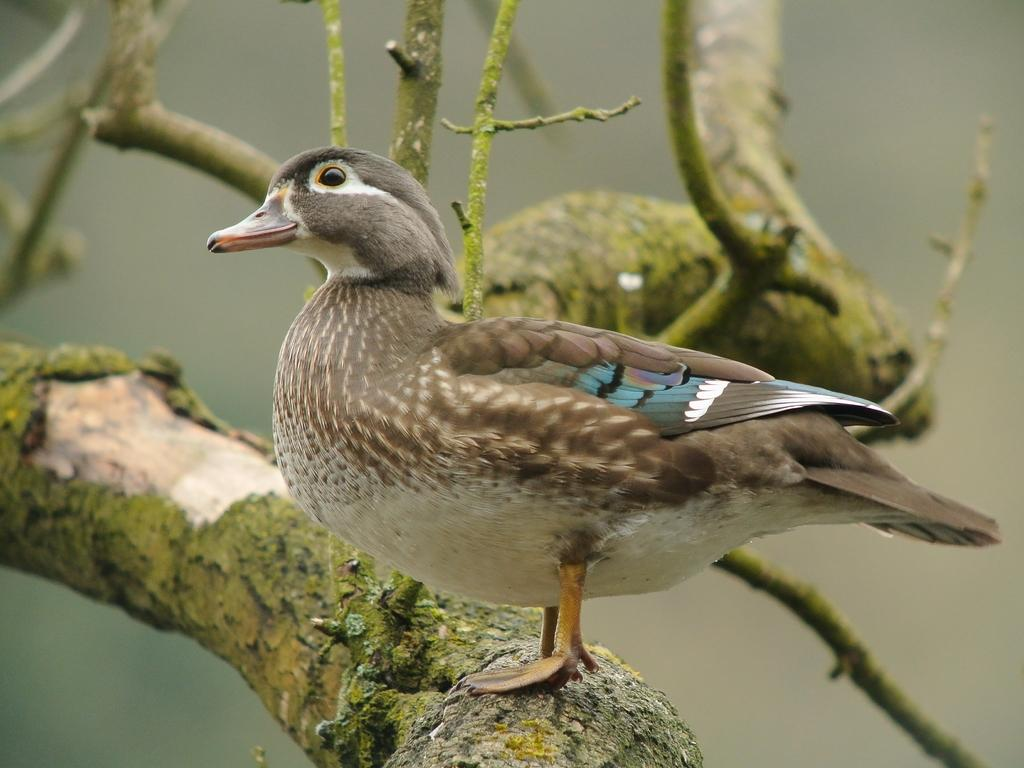Where was the image taken? The image is taken outdoors. What can be seen in the image besides the outdoor setting? There is a tree and a bird on a branch in the image. What type of disgust can be seen on the bird's face in the image? There is no indication of any emotion, let alone disgust, on the bird's face in the image. 